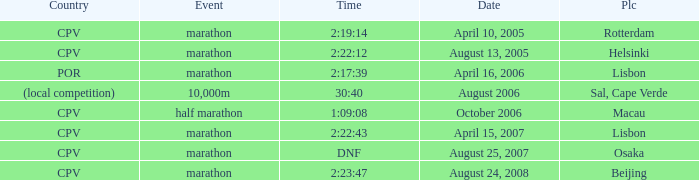What is the Country of the 10,000m Event? (local competition). 